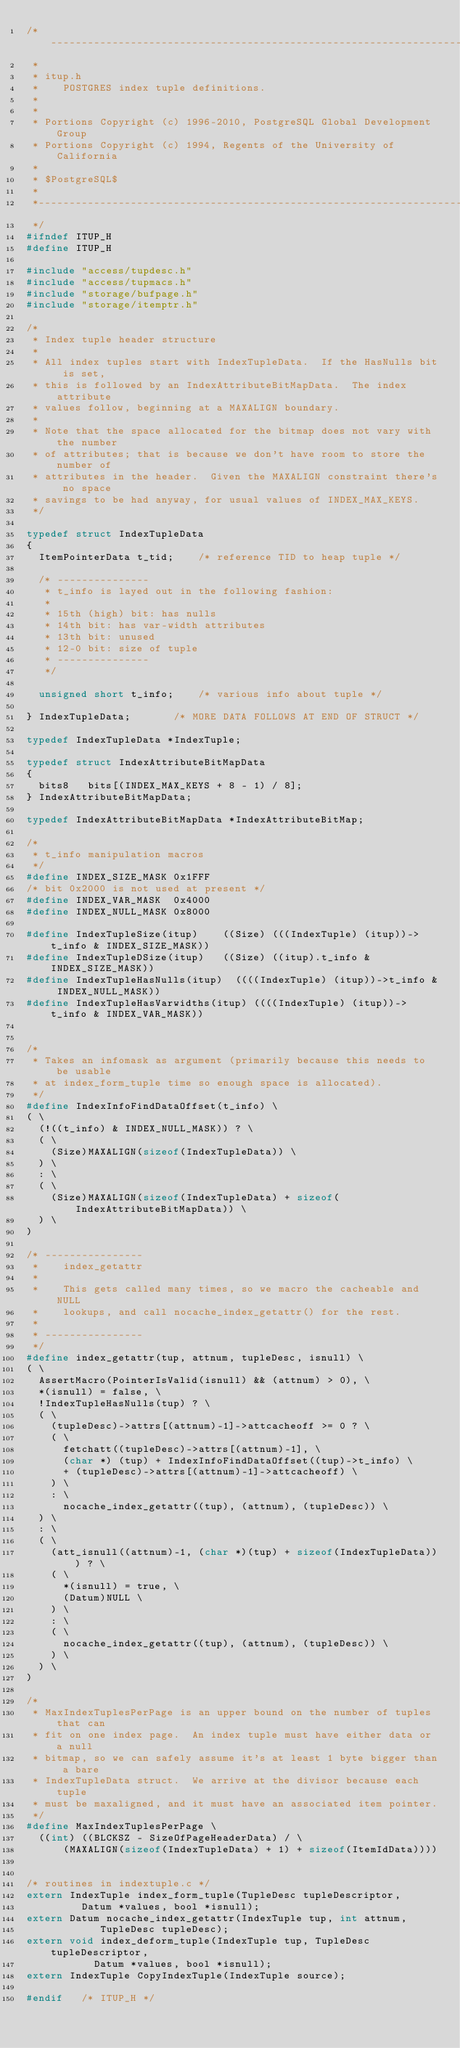<code> <loc_0><loc_0><loc_500><loc_500><_C_>/*-------------------------------------------------------------------------
 *
 * itup.h
 *	  POSTGRES index tuple definitions.
 *
 *
 * Portions Copyright (c) 1996-2010, PostgreSQL Global Development Group
 * Portions Copyright (c) 1994, Regents of the University of California
 *
 * $PostgreSQL$
 *
 *-------------------------------------------------------------------------
 */
#ifndef ITUP_H
#define ITUP_H

#include "access/tupdesc.h"
#include "access/tupmacs.h"
#include "storage/bufpage.h"
#include "storage/itemptr.h"

/*
 * Index tuple header structure
 *
 * All index tuples start with IndexTupleData.	If the HasNulls bit is set,
 * this is followed by an IndexAttributeBitMapData.  The index attribute
 * values follow, beginning at a MAXALIGN boundary.
 *
 * Note that the space allocated for the bitmap does not vary with the number
 * of attributes; that is because we don't have room to store the number of
 * attributes in the header.  Given the MAXALIGN constraint there's no space
 * savings to be had anyway, for usual values of INDEX_MAX_KEYS.
 */

typedef struct IndexTupleData
{
	ItemPointerData t_tid;		/* reference TID to heap tuple */

	/* ---------------
	 * t_info is layed out in the following fashion:
	 *
	 * 15th (high) bit: has nulls
	 * 14th bit: has var-width attributes
	 * 13th bit: unused
	 * 12-0 bit: size of tuple
	 * ---------------
	 */

	unsigned short t_info;		/* various info about tuple */

} IndexTupleData;				/* MORE DATA FOLLOWS AT END OF STRUCT */

typedef IndexTupleData *IndexTuple;

typedef struct IndexAttributeBitMapData
{
	bits8		bits[(INDEX_MAX_KEYS + 8 - 1) / 8];
} IndexAttributeBitMapData;

typedef IndexAttributeBitMapData *IndexAttributeBitMap;

/*
 * t_info manipulation macros
 */
#define INDEX_SIZE_MASK 0x1FFF
/* bit 0x2000 is not used at present */
#define INDEX_VAR_MASK	0x4000
#define INDEX_NULL_MASK 0x8000

#define IndexTupleSize(itup)		((Size) (((IndexTuple) (itup))->t_info & INDEX_SIZE_MASK))
#define IndexTupleDSize(itup)		((Size) ((itup).t_info & INDEX_SIZE_MASK))
#define IndexTupleHasNulls(itup)	((((IndexTuple) (itup))->t_info & INDEX_NULL_MASK))
#define IndexTupleHasVarwidths(itup) ((((IndexTuple) (itup))->t_info & INDEX_VAR_MASK))


/*
 * Takes an infomask as argument (primarily because this needs to be usable
 * at index_form_tuple time so enough space is allocated).
 */
#define IndexInfoFindDataOffset(t_info) \
( \
	(!((t_info) & INDEX_NULL_MASK)) ? \
	( \
		(Size)MAXALIGN(sizeof(IndexTupleData)) \
	) \
	: \
	( \
		(Size)MAXALIGN(sizeof(IndexTupleData) + sizeof(IndexAttributeBitMapData)) \
	) \
)

/* ----------------
 *		index_getattr
 *
 *		This gets called many times, so we macro the cacheable and NULL
 *		lookups, and call nocache_index_getattr() for the rest.
 *
 * ----------------
 */
#define index_getattr(tup, attnum, tupleDesc, isnull) \
( \
	AssertMacro(PointerIsValid(isnull) && (attnum) > 0), \
	*(isnull) = false, \
	!IndexTupleHasNulls(tup) ? \
	( \
		(tupleDesc)->attrs[(attnum)-1]->attcacheoff >= 0 ? \
		( \
			fetchatt((tupleDesc)->attrs[(attnum)-1], \
			(char *) (tup) + IndexInfoFindDataOffset((tup)->t_info) \
			+ (tupleDesc)->attrs[(attnum)-1]->attcacheoff) \
		) \
		: \
			nocache_index_getattr((tup), (attnum), (tupleDesc)) \
	) \
	: \
	( \
		(att_isnull((attnum)-1, (char *)(tup) + sizeof(IndexTupleData))) ? \
		( \
			*(isnull) = true, \
			(Datum)NULL \
		) \
		: \
		( \
			nocache_index_getattr((tup), (attnum), (tupleDesc)) \
		) \
	) \
)

/*
 * MaxIndexTuplesPerPage is an upper bound on the number of tuples that can
 * fit on one index page.  An index tuple must have either data or a null
 * bitmap, so we can safely assume it's at least 1 byte bigger than a bare
 * IndexTupleData struct.  We arrive at the divisor because each tuple
 * must be maxaligned, and it must have an associated item pointer.
 */
#define MaxIndexTuplesPerPage	\
	((int) ((BLCKSZ - SizeOfPageHeaderData) / \
			(MAXALIGN(sizeof(IndexTupleData) + 1) + sizeof(ItemIdData))))


/* routines in indextuple.c */
extern IndexTuple index_form_tuple(TupleDesc tupleDescriptor,
				 Datum *values, bool *isnull);
extern Datum nocache_index_getattr(IndexTuple tup, int attnum,
					  TupleDesc tupleDesc);
extern void index_deform_tuple(IndexTuple tup, TupleDesc tupleDescriptor,
				   Datum *values, bool *isnull);
extern IndexTuple CopyIndexTuple(IndexTuple source);

#endif   /* ITUP_H */
</code> 